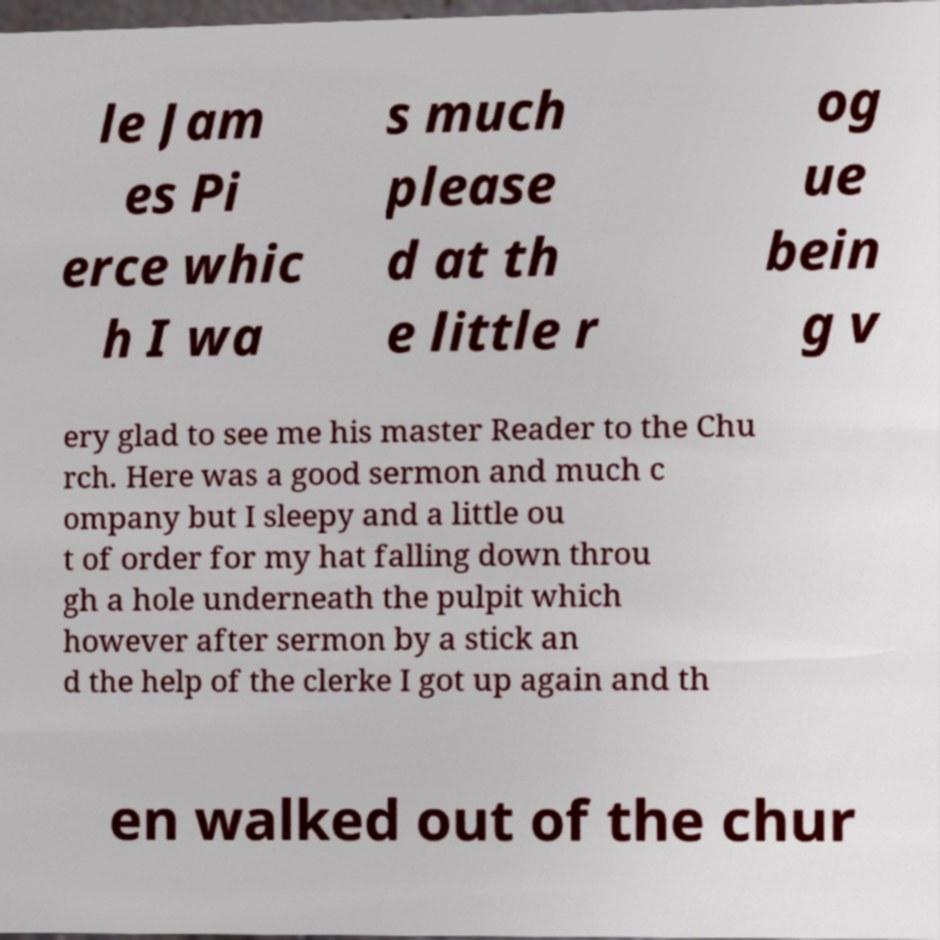I need the written content from this picture converted into text. Can you do that? le Jam es Pi erce whic h I wa s much please d at th e little r og ue bein g v ery glad to see me his master Reader to the Chu rch. Here was a good sermon and much c ompany but I sleepy and a little ou t of order for my hat falling down throu gh a hole underneath the pulpit which however after sermon by a stick an d the help of the clerke I got up again and th en walked out of the chur 